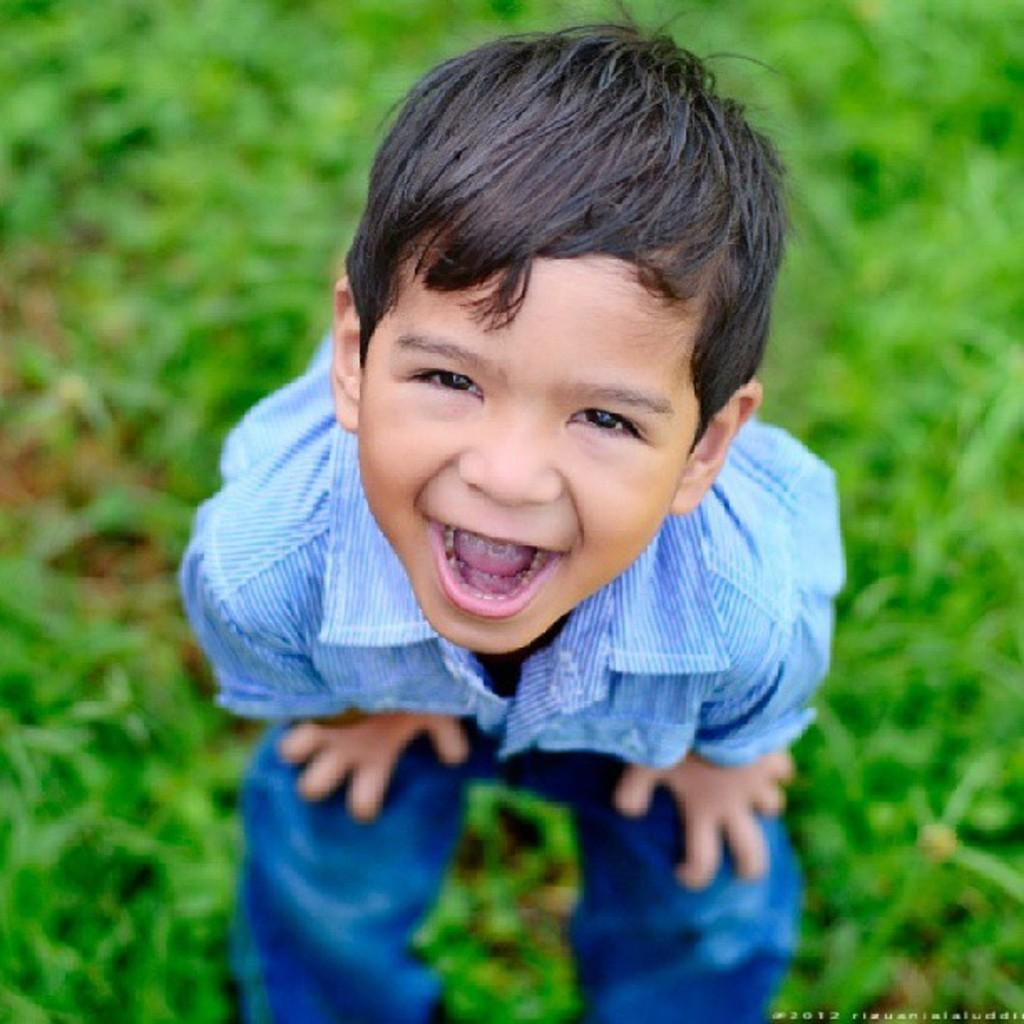Who is in the picture? There is a boy in the picture. What is the boy doing in the picture? The boy is smiling in the picture. What is the ground surface like where the boy is standing? The boy is standing on grass. What is the price of the shoes the boy is wearing in the picture? There is no information about the boy's shoes or their price in the image. 